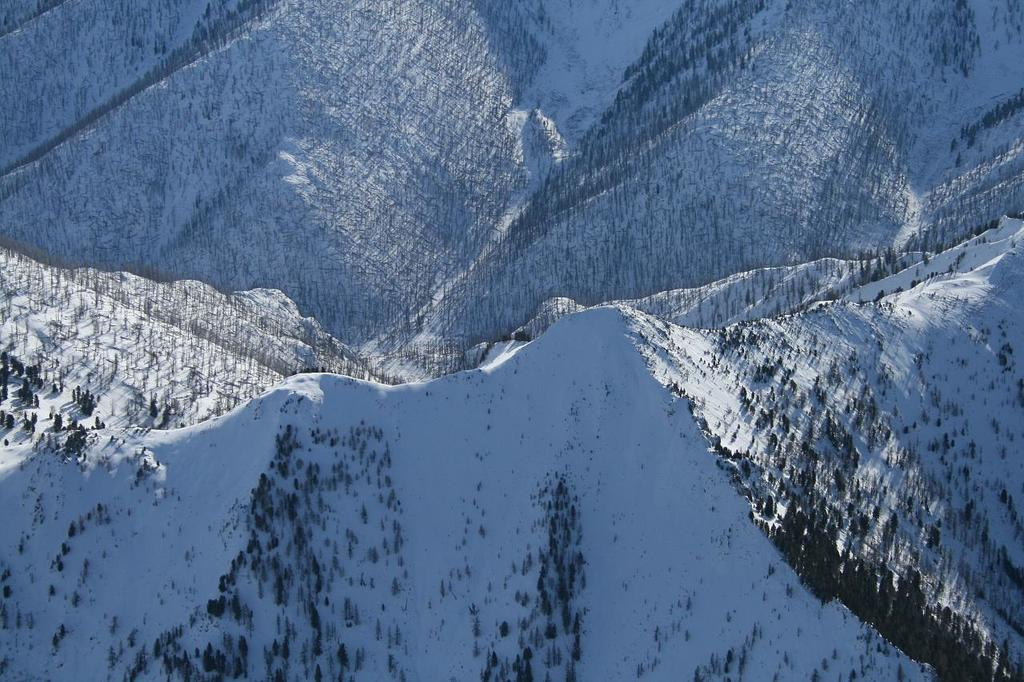What type of landscape is depicted in the image? The image features mountains with trees at the bottom and snow-covered mountains in the background. Can you describe the vegetation present in the image? There are trees at the bottom of the mountains in the image. What is the condition of the mountains in the background? The mountains in the background are covered in snow. What year is printed on the mountain in the image? There is no year printed on the mountain in the image. Can you describe the mouth of the mountain in the image? Mountains do not have mouths, as they are inanimate geological formations. 